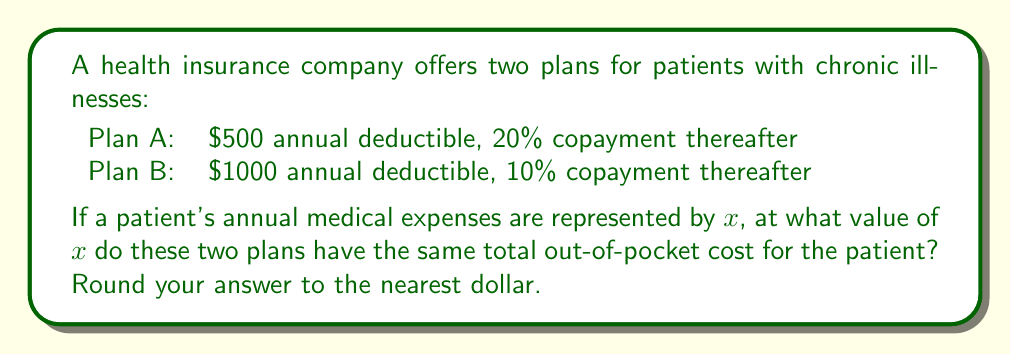Provide a solution to this math problem. Let's approach this step-by-step:

1) First, let's create equations for the out-of-pocket costs for each plan:

   Plan A: $f(x) = \begin{cases}
   x & \text{if } x \leq 500 \\
   500 + 0.20(x - 500) & \text{if } x > 500
   \end{cases}$

   Plan B: $g(x) = \begin{cases}
   x & \text{if } x \leq 1000 \\
   1000 + 0.10(x - 1000) & \text{if } x > 1000
   \end{cases}$

2) We're looking for the point where these plans cost the same, so we need to solve:
   $500 + 0.20(x - 500) = 1000 + 0.10(x - 1000)$

3) Let's simplify the left side:
   $500 + 0.20x - 100 = 1000 + 0.10x - 100$
   $400 + 0.20x = 900 + 0.10x$

4) Subtract 900 from both sides:
   $-500 + 0.20x = 0.10x$

5) Subtract 0.10x from both sides:
   $-500 + 0.10x = 0$

6) Add 500 to both sides:
   $0.10x = 500$

7) Divide both sides by 0.10:
   $x = 5000$

Therefore, the break-even point is at $5000 in annual medical expenses.

8) Let's verify:
   For Plan A: $500 + 0.20(5000 - 500) = 500 + 900 = 1400$
   For Plan B: $1000 + 0.10(5000 - 1000) = 1000 + 400 = 1400$

Both plans indeed result in the same out-of-pocket cost at $5000.
Answer: $5000 